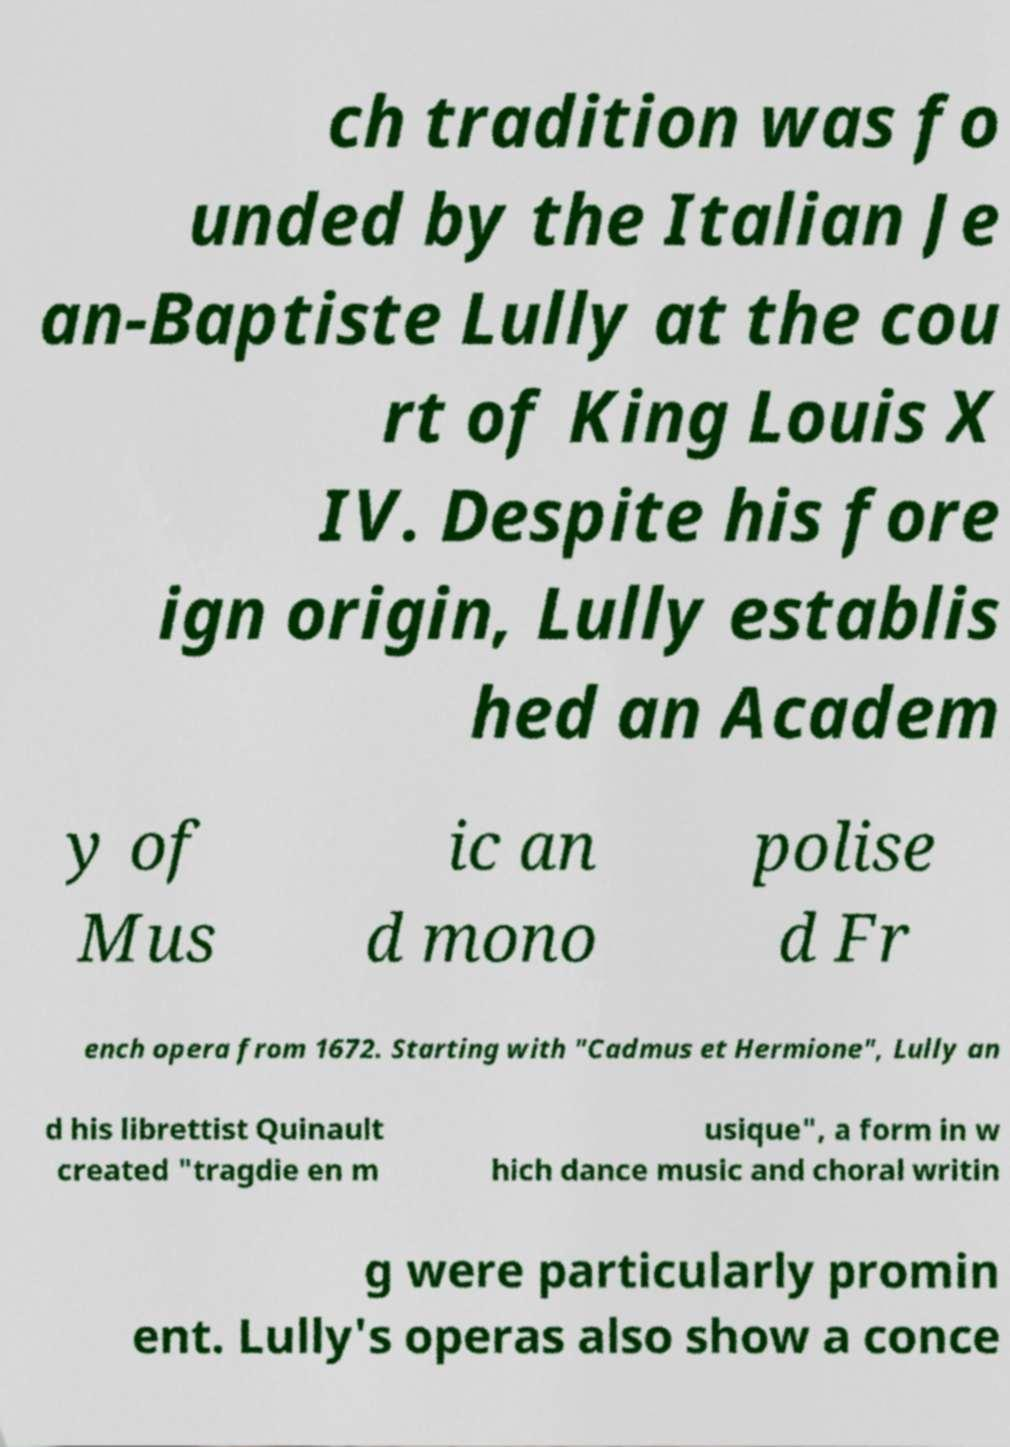For documentation purposes, I need the text within this image transcribed. Could you provide that? ch tradition was fo unded by the Italian Je an-Baptiste Lully at the cou rt of King Louis X IV. Despite his fore ign origin, Lully establis hed an Academ y of Mus ic an d mono polise d Fr ench opera from 1672. Starting with "Cadmus et Hermione", Lully an d his librettist Quinault created "tragdie en m usique", a form in w hich dance music and choral writin g were particularly promin ent. Lully's operas also show a conce 